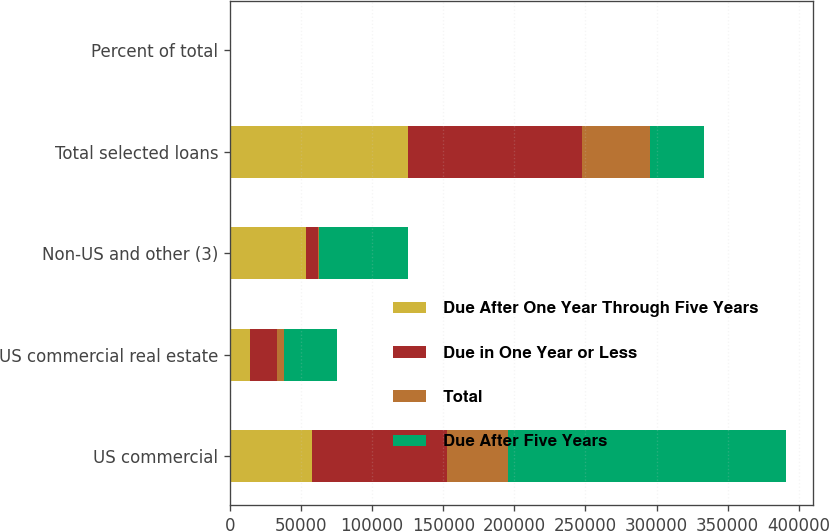Convert chart. <chart><loc_0><loc_0><loc_500><loc_500><stacked_bar_chart><ecel><fcel>US commercial<fcel>US commercial real estate<fcel>Non-US and other (3)<fcel>Total selected loans<fcel>Percent of total<nl><fcel>Due After One Year Through Five Years<fcel>57572<fcel>14073<fcel>53636<fcel>125281<fcel>42<nl><fcel>Due in One Year or Less<fcel>94860<fcel>19164<fcel>8257<fcel>122281<fcel>41<nl><fcel>Total<fcel>42955<fcel>4533<fcel>707<fcel>48195<fcel>17<nl><fcel>Due After Five Years<fcel>195387<fcel>37770<fcel>62600<fcel>37770<fcel>100<nl></chart> 